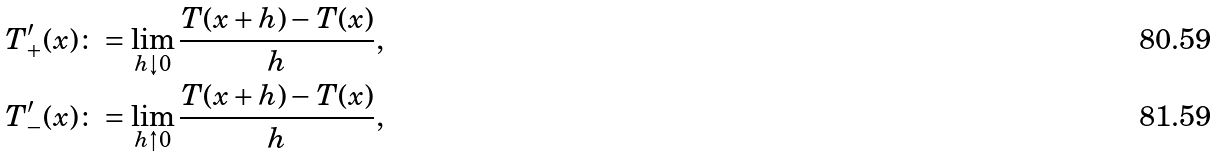<formula> <loc_0><loc_0><loc_500><loc_500>T ^ { \prime } _ { + } ( x ) & \colon = \lim _ { h \downarrow 0 } \frac { T ( x + h ) - T ( x ) } { h } , \\ T ^ { \prime } _ { - } ( x ) & \colon = \lim _ { h \uparrow 0 } \frac { T ( x + h ) - T ( x ) } { h } ,</formula> 